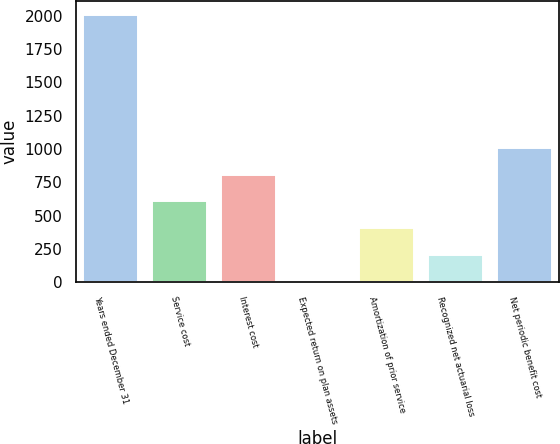<chart> <loc_0><loc_0><loc_500><loc_500><bar_chart><fcel>Years ended December 31<fcel>Service cost<fcel>Interest cost<fcel>Expected return on plan assets<fcel>Amortization of prior service<fcel>Recognized net actuarial loss<fcel>Net periodic benefit cost<nl><fcel>2008<fcel>608<fcel>808<fcel>8<fcel>408<fcel>208<fcel>1008<nl></chart> 